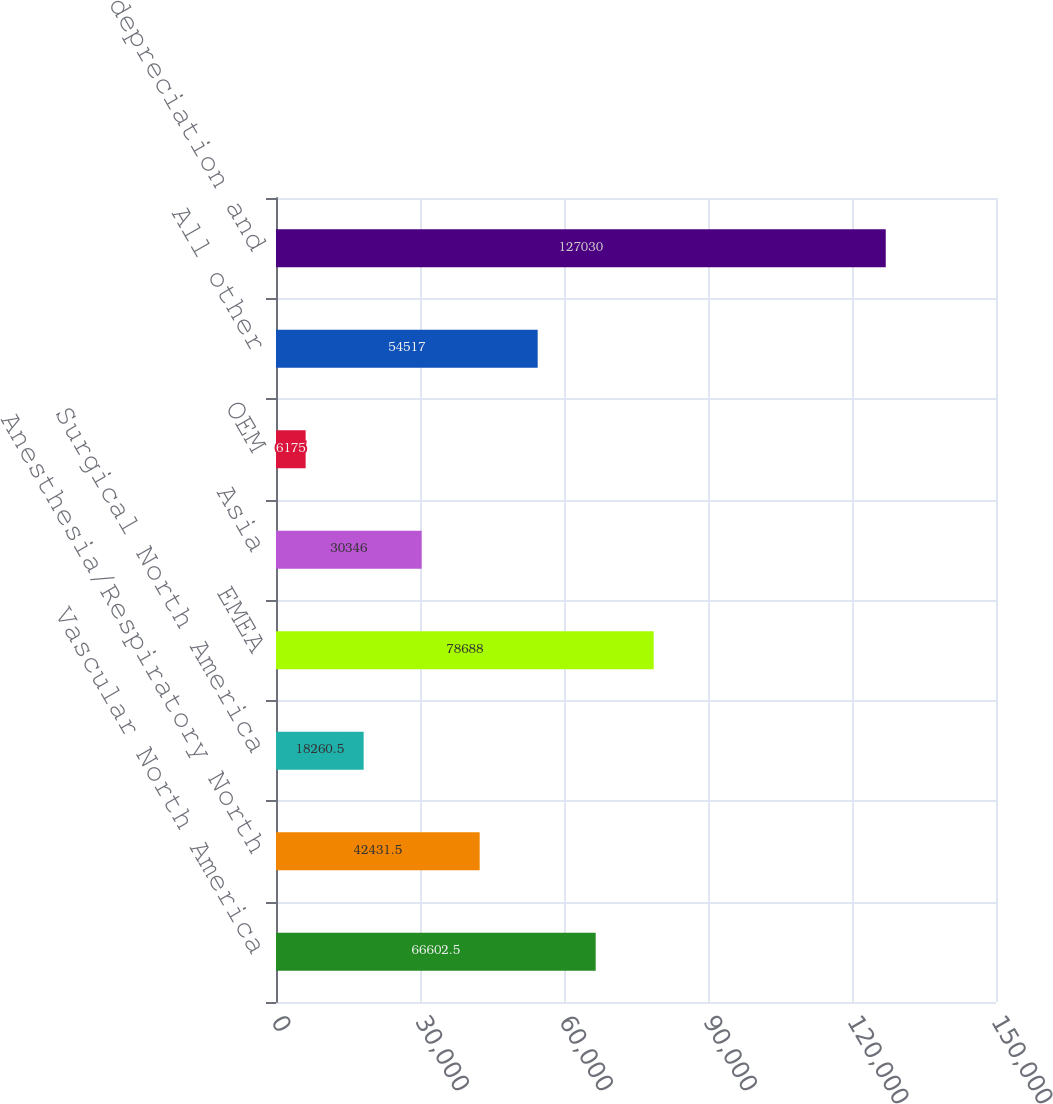Convert chart to OTSL. <chart><loc_0><loc_0><loc_500><loc_500><bar_chart><fcel>Vascular North America<fcel>Anesthesia/Respiratory North<fcel>Surgical North America<fcel>EMEA<fcel>Asia<fcel>OEM<fcel>All other<fcel>Consolidated depreciation and<nl><fcel>66602.5<fcel>42431.5<fcel>18260.5<fcel>78688<fcel>30346<fcel>6175<fcel>54517<fcel>127030<nl></chart> 